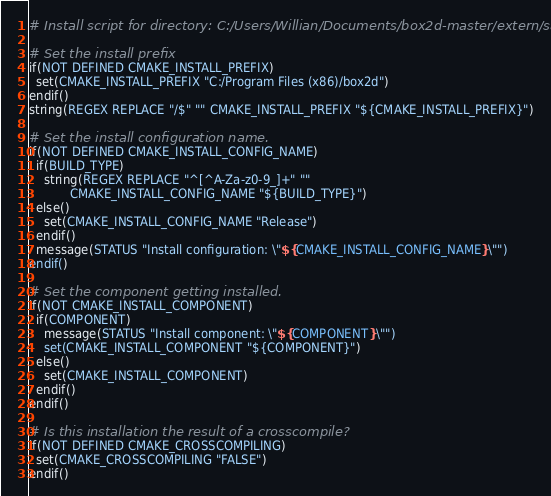<code> <loc_0><loc_0><loc_500><loc_500><_CMake_># Install script for directory: C:/Users/Willian/Documents/box2d-master/extern/sajson

# Set the install prefix
if(NOT DEFINED CMAKE_INSTALL_PREFIX)
  set(CMAKE_INSTALL_PREFIX "C:/Program Files (x86)/box2d")
endif()
string(REGEX REPLACE "/$" "" CMAKE_INSTALL_PREFIX "${CMAKE_INSTALL_PREFIX}")

# Set the install configuration name.
if(NOT DEFINED CMAKE_INSTALL_CONFIG_NAME)
  if(BUILD_TYPE)
    string(REGEX REPLACE "^[^A-Za-z0-9_]+" ""
           CMAKE_INSTALL_CONFIG_NAME "${BUILD_TYPE}")
  else()
    set(CMAKE_INSTALL_CONFIG_NAME "Release")
  endif()
  message(STATUS "Install configuration: \"${CMAKE_INSTALL_CONFIG_NAME}\"")
endif()

# Set the component getting installed.
if(NOT CMAKE_INSTALL_COMPONENT)
  if(COMPONENT)
    message(STATUS "Install component: \"${COMPONENT}\"")
    set(CMAKE_INSTALL_COMPONENT "${COMPONENT}")
  else()
    set(CMAKE_INSTALL_COMPONENT)
  endif()
endif()

# Is this installation the result of a crosscompile?
if(NOT DEFINED CMAKE_CROSSCOMPILING)
  set(CMAKE_CROSSCOMPILING "FALSE")
endif()

</code> 